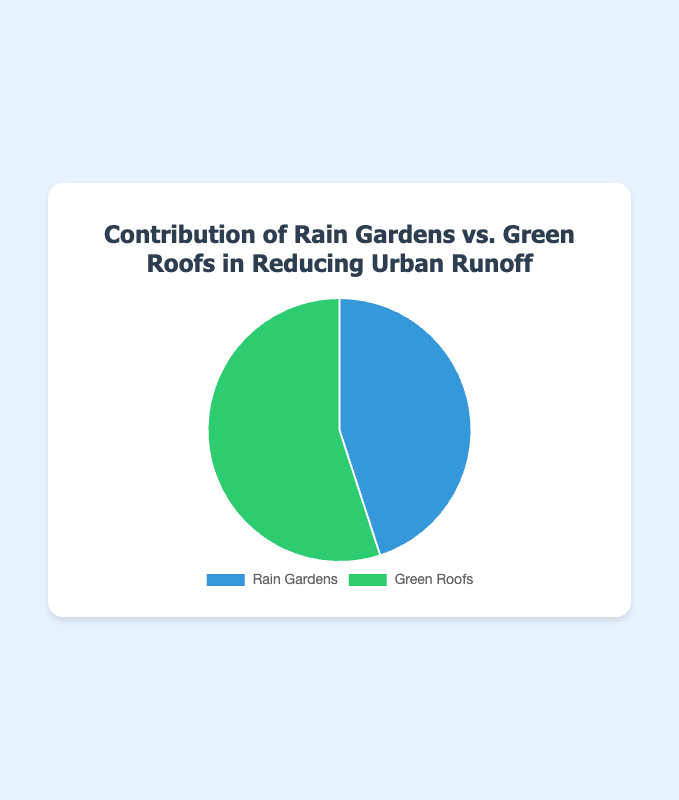What's the dominant method in reducing urban runoff? By observing the pie chart, Green Roofs have a contribution of 55%, while Rain Gardens contribute 45%. Green Roofs have the higher percentage, so they are the dominant method.
Answer: Green Roofs Which method contributes less to reducing urban runoff? The pie chart shows that Rain Gardens contribute 45% while Green Roofs contribute 55%. Since 45% is less than 55%, Rain Gardens contribute less.
Answer: Rain Gardens What is the percentage difference between the contributions of Rain Gardens and Green Roofs? Subtract the smaller percentage (45%) from the larger percentage (55%) to find the difference. The calculation is: 55% - 45% = 10%.
Answer: 10% What's the total contribution percentage for both methods combined? The total contribution percentage for both methods is the sum of their individual percentages: 45% + 55% = 100%.
Answer: 100% What's the difference in contribution between the method with the highest contribution and the average contribution of both methods? First, find the average contribution: (45% + 55%) / 2 = 50%. Then, find the difference between the highest contribution (55%) and the average contribution (50%): 55% - 50% = 5%.
Answer: 5% What color represents Green Roofs in the pie chart? The legend of the pie chart shows that Green Roofs are represented by the color green.
Answer: Green How much more does Green Roofs contribute than Rain Gardens in reducing urban runoff? Green Roofs contribute 55% while Rain Gardens contribute 45%. The difference is calculated as: 55% - 45% = 10%.
Answer: 10% Does any method contribute exactly half of the total reduction? The pie chart shows the contributions of Rain Gardens and Green Roofs as 45% and 55%, respectively. Neither method contributes exactly 50%.
Answer: No If another method were added to the chart with a 20% contribution, what would the new contribution percentage for Green Roofs be? Adding another method with a 20% contribution means the total contribution now is 120%. The new contribution percentage for Green Roofs would be recalculated as: (55 / 120) * 100 ≈ 45.83%.
Answer: 45.83% If the percentage contribution of Rain Gardens were to increase by 10%, how would that affect the overall contribution percentages? Increasing Rain Gardens' contribution by 10% would make it 55%. The total contributions would be 45% (current Green Roofs) + 55% (new Rain Gardens) = 100%. So Rain Gardens and Green Roofs would contribute equally, each at 50%.
Answer: Equal, 50% each 